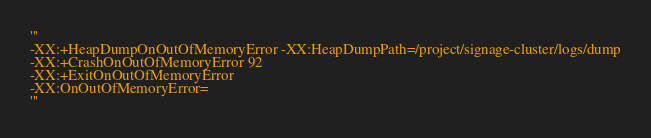Convert code to text. <code><loc_0><loc_0><loc_500><loc_500><_Python_>
'''
-XX:+HeapDumpOnOutOfMemoryError -XX:HeapDumpPath=/project/signage-cluster/logs/dump
-XX:+CrashOnOutOfMemoryError 92
-XX:+ExitOnOutOfMemoryError
-XX:OnOutOfMemoryError=
'''

</code> 